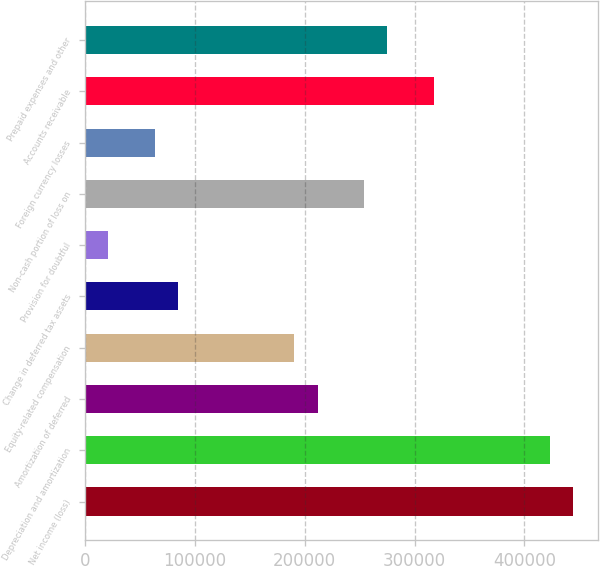Convert chart. <chart><loc_0><loc_0><loc_500><loc_500><bar_chart><fcel>Net income (loss)<fcel>Depreciation and amortization<fcel>Amortization of deferred<fcel>Equity-related compensation<fcel>Change in deferred tax assets<fcel>Provision for doubtful<fcel>Non-cash portion of loss on<fcel>Foreign currency losses<fcel>Accounts receivable<fcel>Prepaid expenses and other<nl><fcel>444538<fcel>423376<fcel>211753<fcel>190591<fcel>84779.2<fcel>21292.3<fcel>254078<fcel>63616.9<fcel>317564<fcel>275240<nl></chart> 